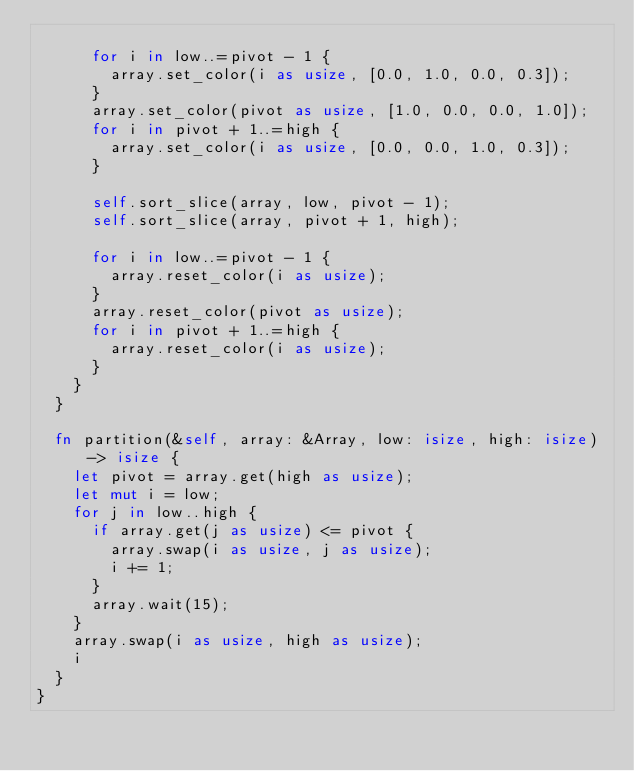<code> <loc_0><loc_0><loc_500><loc_500><_Rust_>
      for i in low..=pivot - 1 {
        array.set_color(i as usize, [0.0, 1.0, 0.0, 0.3]);
      }
      array.set_color(pivot as usize, [1.0, 0.0, 0.0, 1.0]);
      for i in pivot + 1..=high {
        array.set_color(i as usize, [0.0, 0.0, 1.0, 0.3]);
      }

      self.sort_slice(array, low, pivot - 1);
      self.sort_slice(array, pivot + 1, high);

      for i in low..=pivot - 1 {
        array.reset_color(i as usize);
      }
      array.reset_color(pivot as usize);
      for i in pivot + 1..=high {
        array.reset_color(i as usize);
      }
    }
  }

  fn partition(&self, array: &Array, low: isize, high: isize) -> isize {
    let pivot = array.get(high as usize);
    let mut i = low;
    for j in low..high {
      if array.get(j as usize) <= pivot {
        array.swap(i as usize, j as usize);
        i += 1;
      }
      array.wait(15);
    }
    array.swap(i as usize, high as usize);
    i
  }
}
</code> 